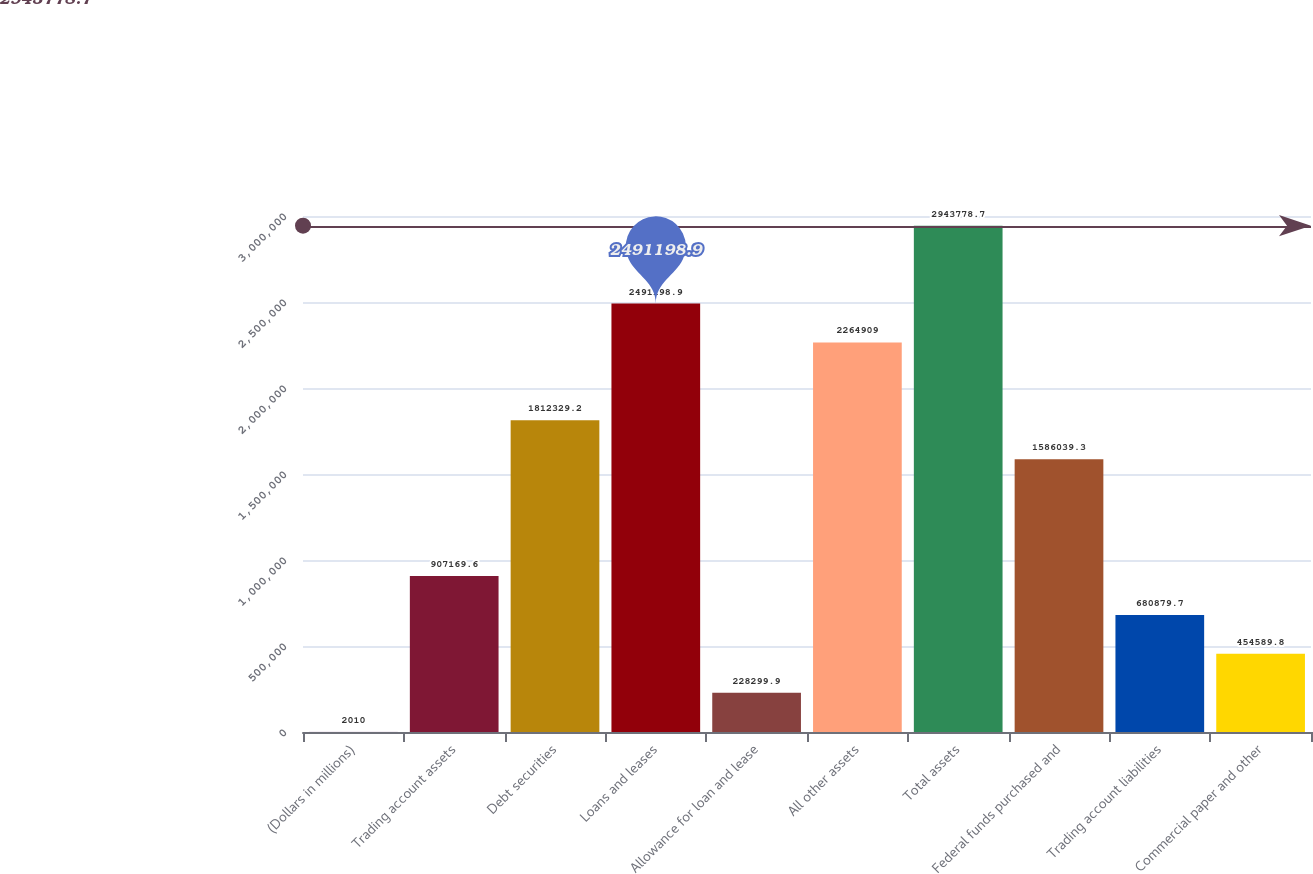Convert chart. <chart><loc_0><loc_0><loc_500><loc_500><bar_chart><fcel>(Dollars in millions)<fcel>Trading account assets<fcel>Debt securities<fcel>Loans and leases<fcel>Allowance for loan and lease<fcel>All other assets<fcel>Total assets<fcel>Federal funds purchased and<fcel>Trading account liabilities<fcel>Commercial paper and other<nl><fcel>2010<fcel>907170<fcel>1.81233e+06<fcel>2.4912e+06<fcel>228300<fcel>2.26491e+06<fcel>2.94378e+06<fcel>1.58604e+06<fcel>680880<fcel>454590<nl></chart> 